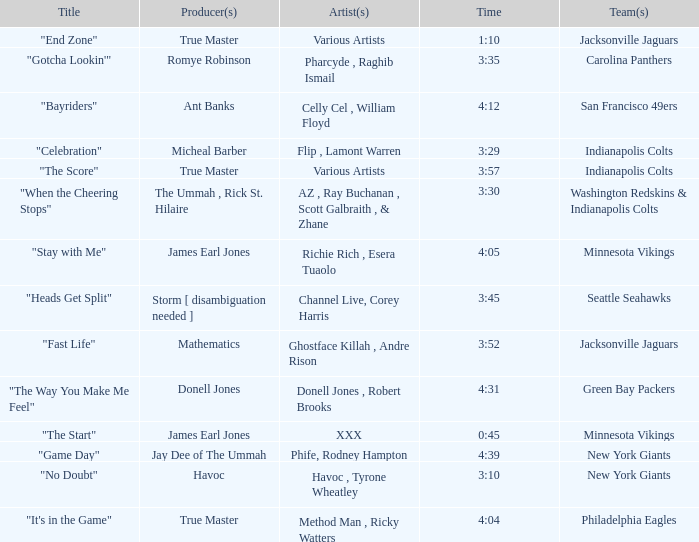Who is the artist of the New York Giants track "No Doubt"? Havoc , Tyrone Wheatley. 